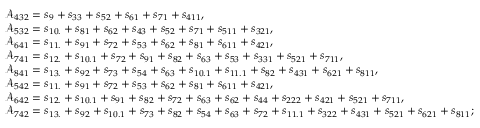<formula> <loc_0><loc_0><loc_500><loc_500>\begin{array} { r l } & { \mathcal { A } _ { 4 3 2 } = s _ { 9 } + s _ { 3 3 } + s _ { 5 2 } + s _ { 6 1 } + s _ { 7 1 } + s _ { 4 1 1 } , } \\ & { \mathcal { A } _ { 5 3 2 } = s _ { 1 0 . } + s _ { 8 1 } + s _ { 6 2 } + s _ { 4 3 } + s _ { 5 2 } + s _ { 7 1 } + s _ { 5 1 1 } + s _ { 3 2 1 } , } \\ & { \mathcal { A } _ { 6 4 1 } = s _ { 1 1 . } + s _ { 9 1 } + s _ { 7 2 } + s _ { 5 3 } + s _ { 6 2 } + s _ { 8 1 } + s _ { 6 1 1 } + s _ { 4 2 1 } , } \\ & { \mathcal { A } _ { 7 4 1 } = s _ { 1 2 . } + s _ { 1 0 . 1 } + s _ { 7 2 } + s _ { 9 1 } + s _ { 8 2 } + s _ { 6 3 } + s _ { 5 3 } + s _ { 3 3 1 } + s _ { 5 2 1 } + s _ { 7 1 1 } , } \\ & { \mathcal { A } _ { 8 4 1 } = s _ { 1 3 . } + s _ { 9 2 } + s _ { 7 3 } + s _ { 5 4 } + s _ { 6 3 } + s _ { 1 0 . 1 } + s _ { 1 1 . 1 } + s _ { 8 2 } + s _ { 4 3 1 } + s _ { 6 2 1 } + s _ { 8 1 1 } , } \\ & { \mathcal { A } _ { 5 4 2 } = s _ { 1 1 . } + s _ { 9 1 } + s _ { 7 2 } + s _ { 5 3 } + s _ { 6 2 } + s _ { 8 1 } + s _ { 6 1 1 } + s _ { 4 2 1 } , } \\ & { \mathcal { A } _ { 6 4 2 } = s _ { 1 2 . } + s _ { 1 0 . 1 } + s _ { 9 1 } + s _ { 8 2 } + s _ { 7 2 } + s _ { 6 3 } + s _ { 6 2 } + s _ { 4 4 } + s _ { 2 2 2 } + s _ { 4 2 1 } + s _ { 5 2 1 } + s _ { 7 1 1 } , } \\ & { \mathcal { A } _ { 7 4 2 } = s _ { 1 3 . } + s _ { 9 2 } + s _ { 1 0 . 1 } + s _ { 7 3 } + s _ { 8 2 } + s _ { 5 4 } + s _ { 6 3 } + s _ { 7 2 } + s _ { 1 1 . 1 } + s _ { 3 2 2 } + s _ { 4 3 1 } + s _ { 5 2 1 } + s _ { 6 2 1 } + s _ { 8 1 1 } ; } \end{array}</formula> 